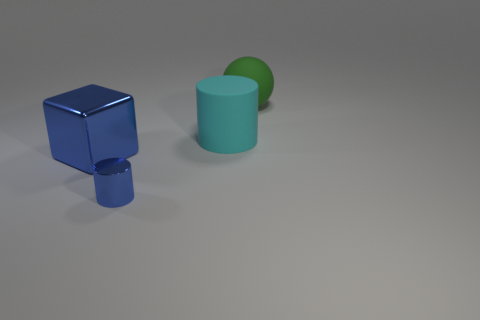There is a big object that is right of the blue metallic cylinder and in front of the sphere; what is its material?
Make the answer very short. Rubber. Does the big object that is on the right side of the cyan rubber cylinder have the same material as the tiny blue cylinder?
Ensure brevity in your answer.  No. What material is the green thing?
Offer a terse response. Rubber. How big is the object that is to the left of the tiny blue shiny thing?
Ensure brevity in your answer.  Large. Is there any other thing that has the same color as the small metallic thing?
Offer a very short reply. Yes. There is a big rubber object behind the rubber object that is on the left side of the large rubber sphere; is there a cube that is to the right of it?
Offer a terse response. No. Does the block behind the blue metallic cylinder have the same color as the rubber ball?
Your response must be concise. No. How many spheres are either red metallic objects or small blue metallic things?
Give a very brief answer. 0. What is the shape of the big rubber object that is behind the large matte object in front of the green thing?
Your answer should be very brief. Sphere. There is a blue thing that is on the left side of the metallic object that is in front of the large shiny thing left of the blue cylinder; what is its size?
Keep it short and to the point. Large. 